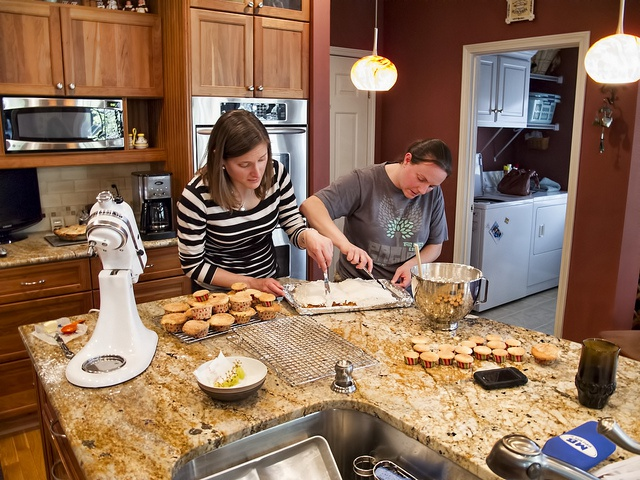Describe the objects in this image and their specific colors. I can see dining table in gray, tan, and lightgray tones, people in gray, black, maroon, lightgray, and brown tones, people in gray, black, maroon, and tan tones, sink in gray, black, and maroon tones, and microwave in gray, black, lightgray, and darkgray tones in this image. 